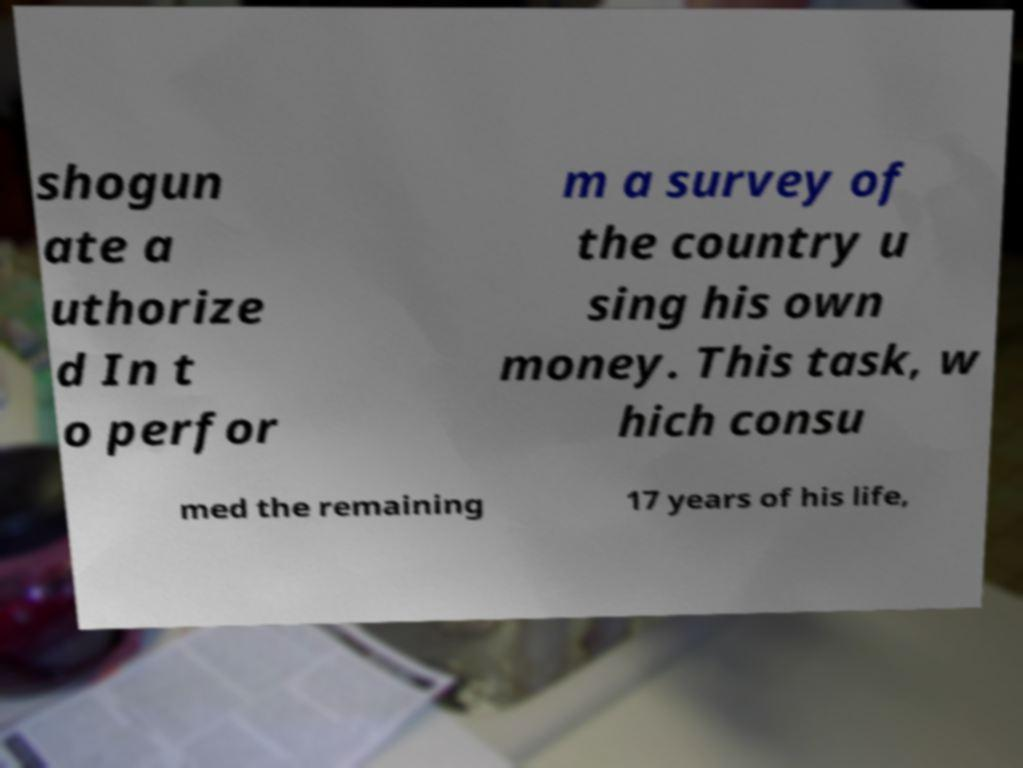Could you extract and type out the text from this image? shogun ate a uthorize d In t o perfor m a survey of the country u sing his own money. This task, w hich consu med the remaining 17 years of his life, 